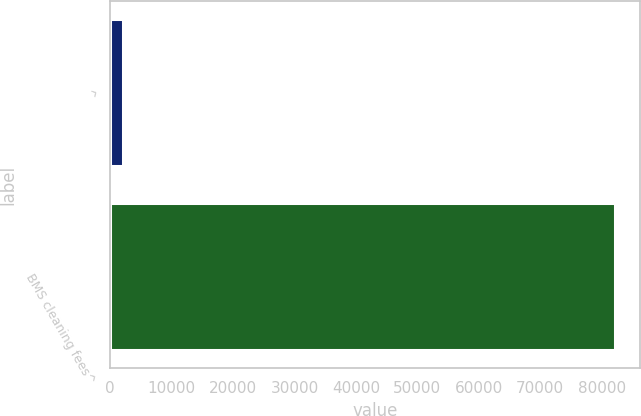Convert chart to OTSL. <chart><loc_0><loc_0><loc_500><loc_500><bar_chart><fcel>^<fcel>BMS cleaning fees^<nl><fcel>2015<fcel>82113<nl></chart> 